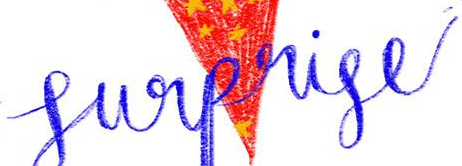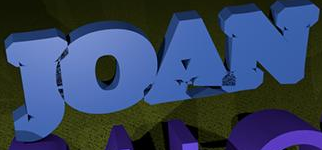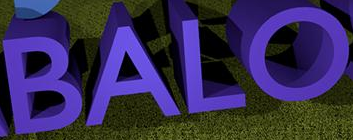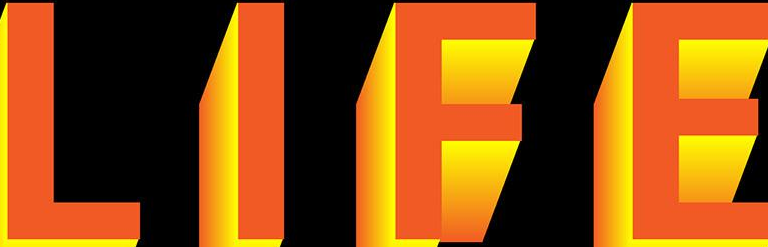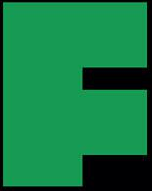Read the text from these images in sequence, separated by a semicolon. Surprise; JOAN; BALO; LIFE; F 